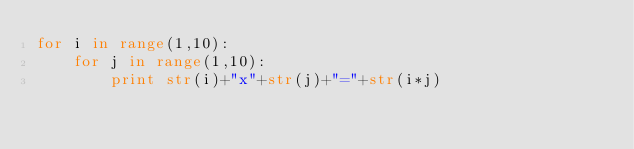Convert code to text. <code><loc_0><loc_0><loc_500><loc_500><_Python_>for i in range(1,10):
	for j in range(1,10):
		print str(i)+"x"+str(j)+"="+str(i*j)

</code> 